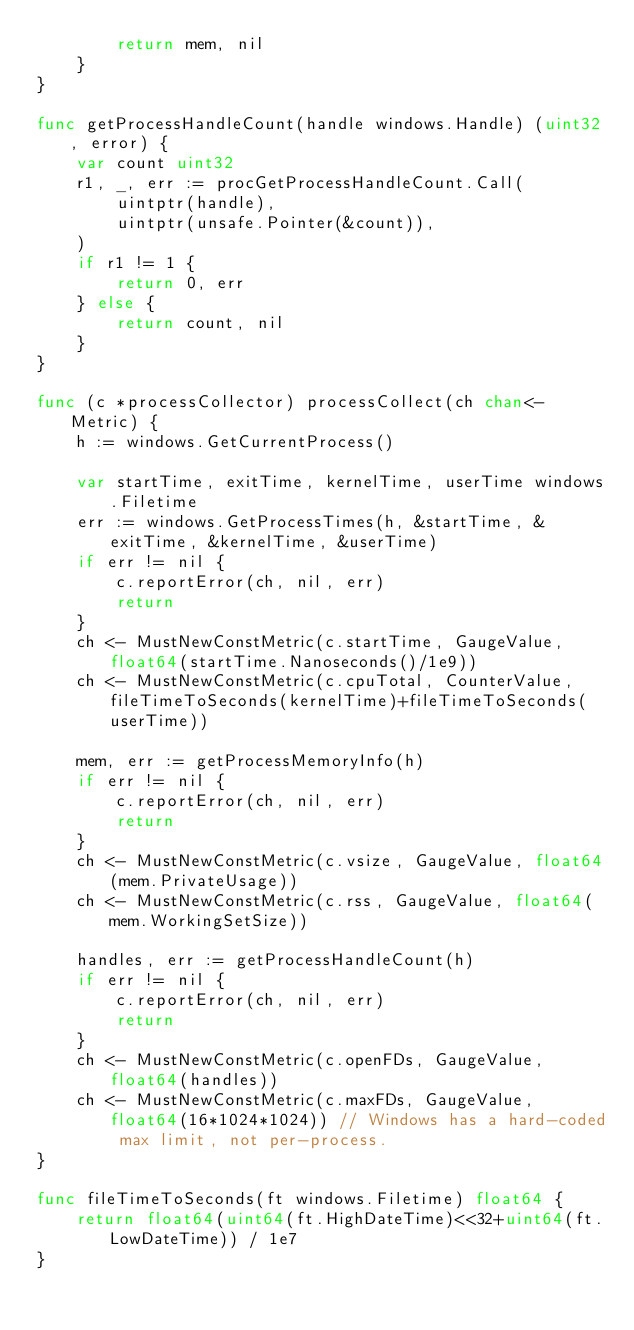Convert code to text. <code><loc_0><loc_0><loc_500><loc_500><_Go_>		return mem, nil
	}
}

func getProcessHandleCount(handle windows.Handle) (uint32, error) {
	var count uint32
	r1, _, err := procGetProcessHandleCount.Call(
		uintptr(handle),
		uintptr(unsafe.Pointer(&count)),
	)
	if r1 != 1 {
		return 0, err
	} else {
		return count, nil
	}
}

func (c *processCollector) processCollect(ch chan<- Metric) {
	h := windows.GetCurrentProcess()
	
	var startTime, exitTime, kernelTime, userTime windows.Filetime
	err := windows.GetProcessTimes(h, &startTime, &exitTime, &kernelTime, &userTime)
	if err != nil {
		c.reportError(ch, nil, err)
		return
	}
	ch <- MustNewConstMetric(c.startTime, GaugeValue, float64(startTime.Nanoseconds()/1e9))
	ch <- MustNewConstMetric(c.cpuTotal, CounterValue, fileTimeToSeconds(kernelTime)+fileTimeToSeconds(userTime))

	mem, err := getProcessMemoryInfo(h)
	if err != nil {
		c.reportError(ch, nil, err)
		return
	}
	ch <- MustNewConstMetric(c.vsize, GaugeValue, float64(mem.PrivateUsage))
	ch <- MustNewConstMetric(c.rss, GaugeValue, float64(mem.WorkingSetSize))

	handles, err := getProcessHandleCount(h)
	if err != nil {
		c.reportError(ch, nil, err)
		return
	}
	ch <- MustNewConstMetric(c.openFDs, GaugeValue, float64(handles))
	ch <- MustNewConstMetric(c.maxFDs, GaugeValue, float64(16*1024*1024)) // Windows has a hard-coded max limit, not per-process.
}

func fileTimeToSeconds(ft windows.Filetime) float64 {
	return float64(uint64(ft.HighDateTime)<<32+uint64(ft.LowDateTime)) / 1e7
}
</code> 